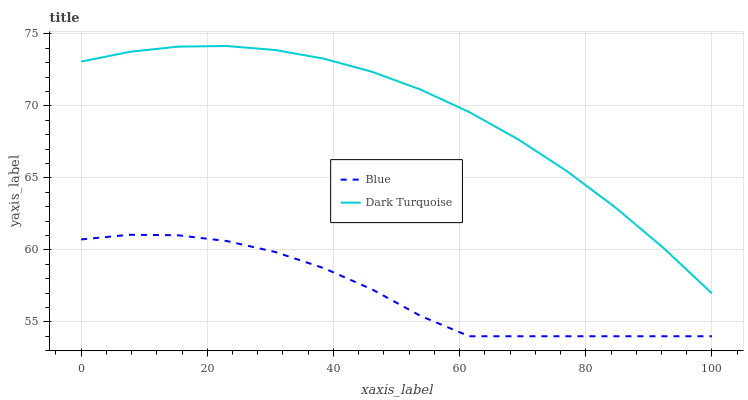Does Blue have the minimum area under the curve?
Answer yes or no. Yes. Does Dark Turquoise have the maximum area under the curve?
Answer yes or no. Yes. Does Dark Turquoise have the minimum area under the curve?
Answer yes or no. No. Is Dark Turquoise the smoothest?
Answer yes or no. Yes. Is Blue the roughest?
Answer yes or no. Yes. Is Dark Turquoise the roughest?
Answer yes or no. No. Does Dark Turquoise have the lowest value?
Answer yes or no. No. Is Blue less than Dark Turquoise?
Answer yes or no. Yes. Is Dark Turquoise greater than Blue?
Answer yes or no. Yes. Does Blue intersect Dark Turquoise?
Answer yes or no. No. 